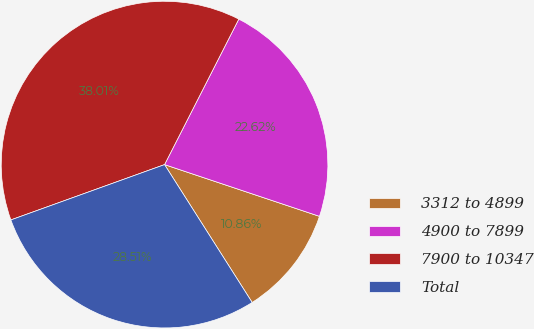Convert chart to OTSL. <chart><loc_0><loc_0><loc_500><loc_500><pie_chart><fcel>3312 to 4899<fcel>4900 to 7899<fcel>7900 to 10347<fcel>Total<nl><fcel>10.86%<fcel>22.62%<fcel>38.01%<fcel>28.51%<nl></chart> 